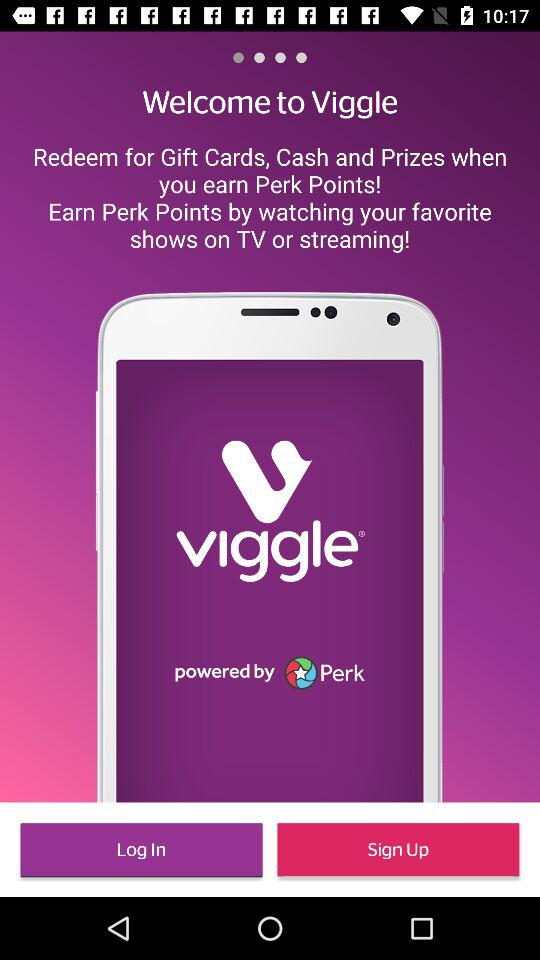What is the name of the application? The name of the application is "Viggle". 